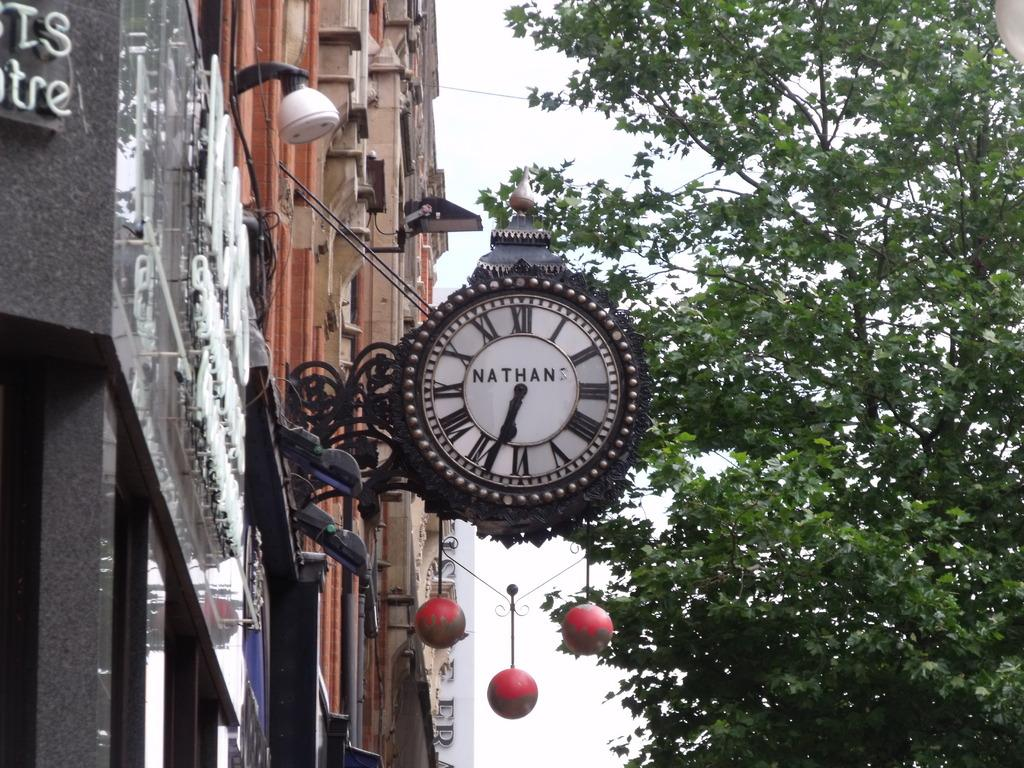<image>
Share a concise interpretation of the image provided. A clock sign with Nathans written in the center of it. 